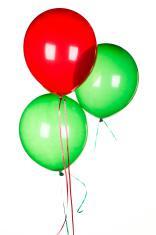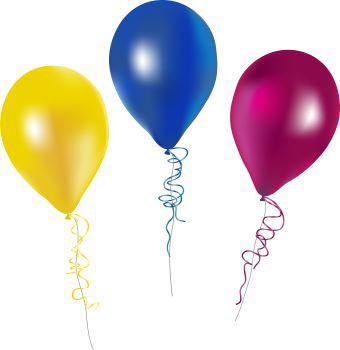The first image is the image on the left, the second image is the image on the right. For the images displayed, is the sentence "There is a heart shaped balloon" factually correct? Answer yes or no. No. The first image is the image on the left, the second image is the image on the right. Evaluate the accuracy of this statement regarding the images: "There are two red balloons and two green balloons". Is it true? Answer yes or no. No. 